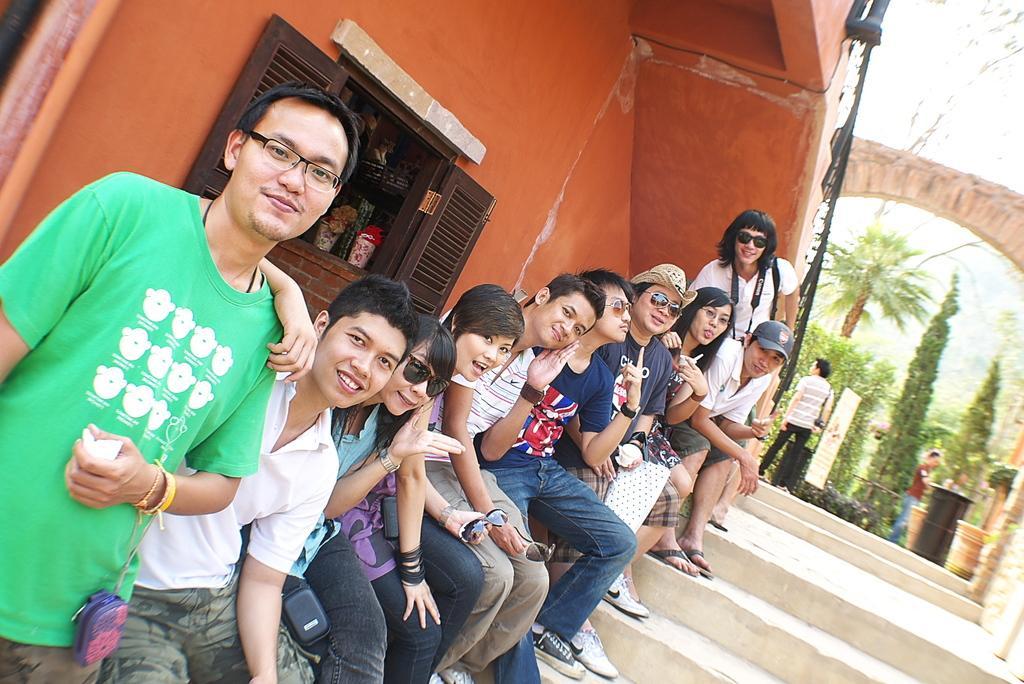In one or two sentences, can you explain what this image depicts? In this image there are two people standing and rest all sitting one after the other on the left side there is a window and on the right side there is the stair and at the back we can see some trees. 